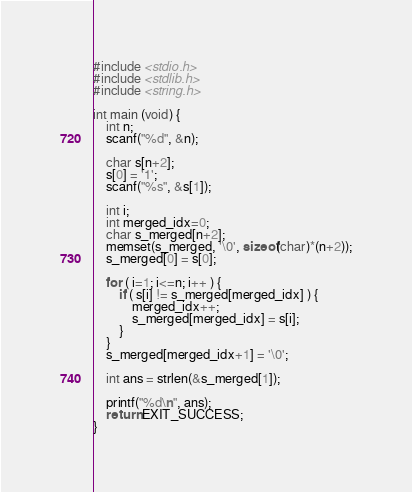<code> <loc_0><loc_0><loc_500><loc_500><_C_>#include <stdio.h>
#include <stdlib.h>
#include <string.h>

int main (void) {
    int n;
    scanf("%d", &n);

    char s[n+2];
    s[0] = '1';
    scanf("%s", &s[1]);

    int i;
    int merged_idx=0;
    char s_merged[n+2];
    memset(s_merged, '\0', sizeof(char)*(n+2));
    s_merged[0] = s[0];

    for ( i=1; i<=n; i++ ) {
        if ( s[i] != s_merged[merged_idx] ) {
            merged_idx++;
            s_merged[merged_idx] = s[i];
        }
    }
    s_merged[merged_idx+1] = '\0';

    int ans = strlen(&s_merged[1]);

    printf("%d\n", ans);
    return EXIT_SUCCESS;
}
</code> 